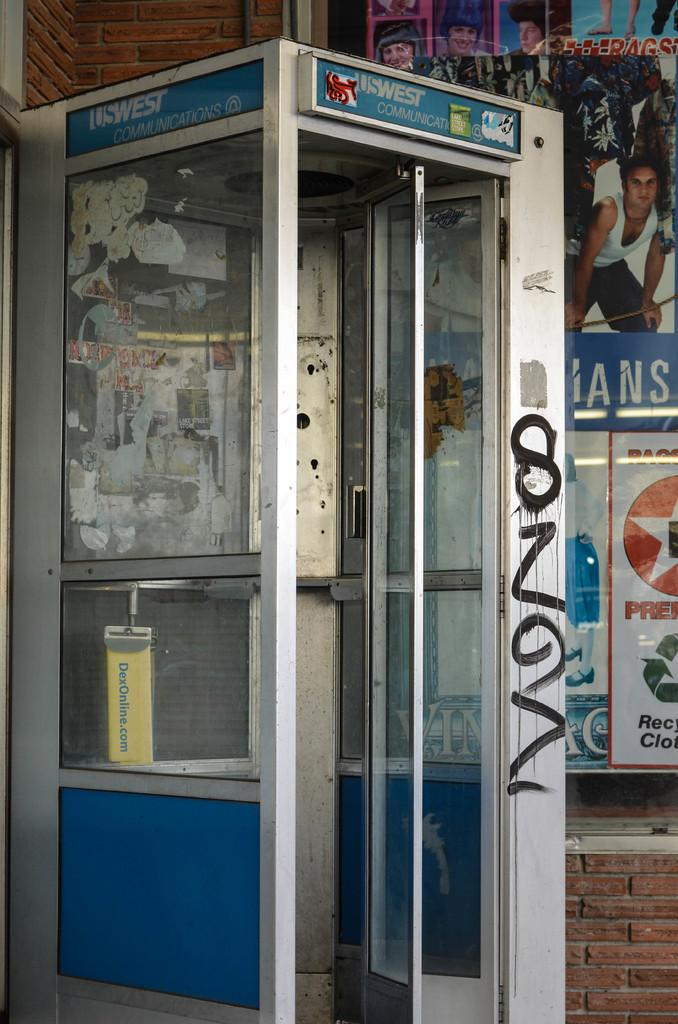What type of room is shown in the image? The image depicts a small room. What feature allows natural light to enter the room? The room has glass windows and a glass door. Where are the posters located in the room? The posters are on the right side of the room. What material is used for the walls on the left and bottom sides of the room? The left and bottom sides of the room have a brick wall. What type of pickle is sitting on the chair in the image? There is no pickle or chair present in the image. 